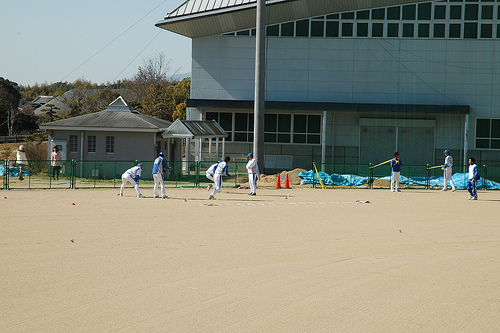<image>
Is there a ground under the roof? No. The ground is not positioned under the roof. The vertical relationship between these objects is different. Is the people next to the building? Yes. The people is positioned adjacent to the building, located nearby in the same general area. 